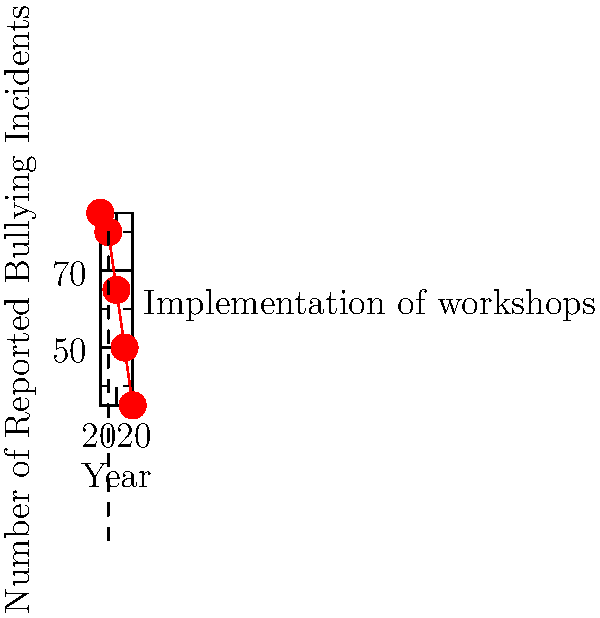Based on the line graph showing reported bullying incidents from 2018 to 2022, what was the percentage decrease in incidents from the year workshops were implemented to the final year shown? To solve this problem, we need to follow these steps:

1. Identify the year workshops were implemented: 2019
2. Find the number of incidents in 2019: 80
3. Identify the final year shown: 2022
4. Find the number of incidents in 2022: 35
5. Calculate the percentage decrease using the formula:
   Percentage decrease = $\frac{\text{Initial value} - \text{Final value}}{\text{Initial value}} \times 100$

6. Plug in the values:
   Percentage decrease = $\frac{80 - 35}{80} \times 100$

7. Simplify:
   Percentage decrease = $\frac{45}{80} \times 100 = 0.5625 \times 100 = 56.25\%$

Therefore, the percentage decrease in reported bullying incidents from 2019 to 2022 is 56.25%.
Answer: 56.25% 